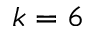Convert formula to latex. <formula><loc_0><loc_0><loc_500><loc_500>k = 6</formula> 